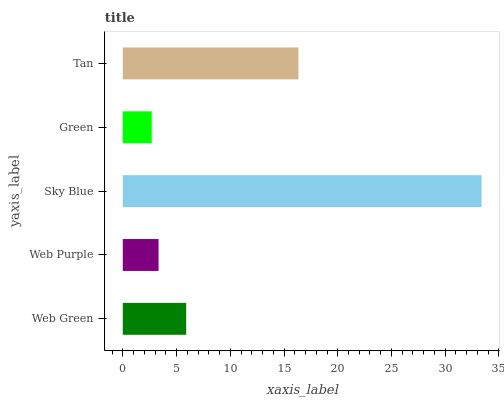Is Green the minimum?
Answer yes or no. Yes. Is Sky Blue the maximum?
Answer yes or no. Yes. Is Web Purple the minimum?
Answer yes or no. No. Is Web Purple the maximum?
Answer yes or no. No. Is Web Green greater than Web Purple?
Answer yes or no. Yes. Is Web Purple less than Web Green?
Answer yes or no. Yes. Is Web Purple greater than Web Green?
Answer yes or no. No. Is Web Green less than Web Purple?
Answer yes or no. No. Is Web Green the high median?
Answer yes or no. Yes. Is Web Green the low median?
Answer yes or no. Yes. Is Tan the high median?
Answer yes or no. No. Is Sky Blue the low median?
Answer yes or no. No. 